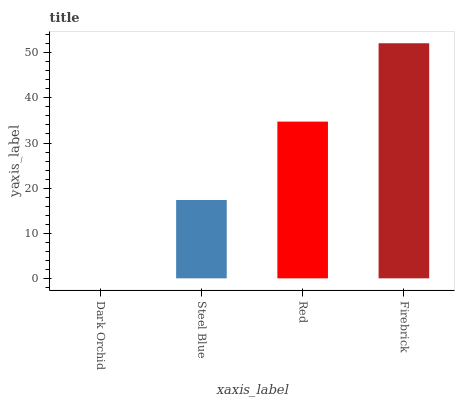Is Dark Orchid the minimum?
Answer yes or no. Yes. Is Firebrick the maximum?
Answer yes or no. Yes. Is Steel Blue the minimum?
Answer yes or no. No. Is Steel Blue the maximum?
Answer yes or no. No. Is Steel Blue greater than Dark Orchid?
Answer yes or no. Yes. Is Dark Orchid less than Steel Blue?
Answer yes or no. Yes. Is Dark Orchid greater than Steel Blue?
Answer yes or no. No. Is Steel Blue less than Dark Orchid?
Answer yes or no. No. Is Red the high median?
Answer yes or no. Yes. Is Steel Blue the low median?
Answer yes or no. Yes. Is Firebrick the high median?
Answer yes or no. No. Is Firebrick the low median?
Answer yes or no. No. 